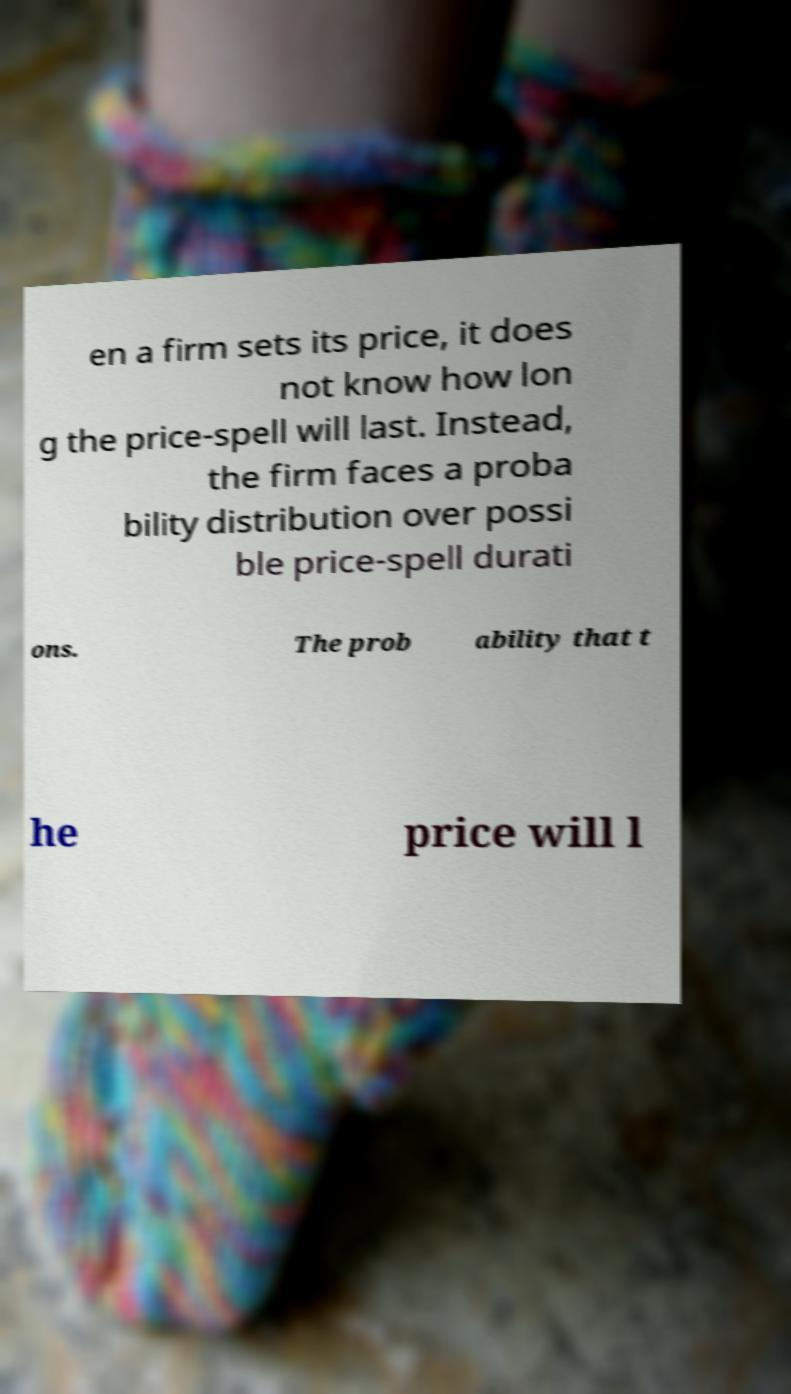For documentation purposes, I need the text within this image transcribed. Could you provide that? en a firm sets its price, it does not know how lon g the price-spell will last. Instead, the firm faces a proba bility distribution over possi ble price-spell durati ons. The prob ability that t he price will l 